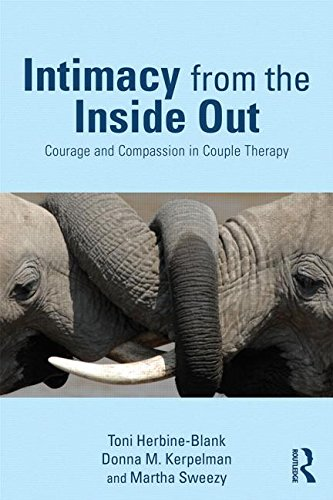Is this book related to Medical Books? Yes, this book is somewhat related to the broader field of Medical Books, particularly focusing on psychological aspects of therapy and mental health. 